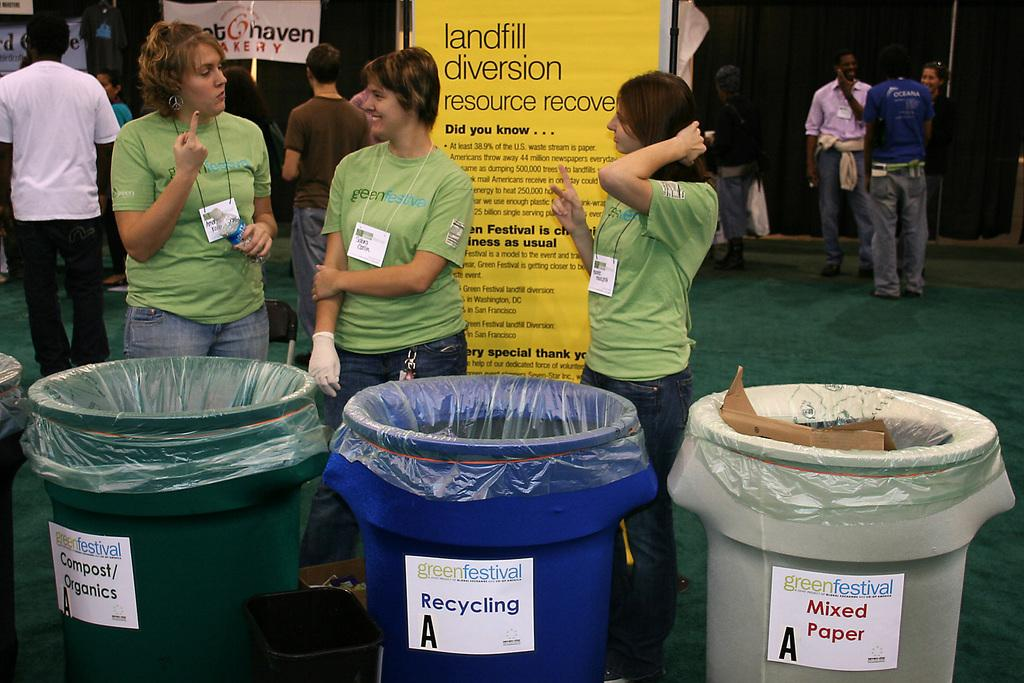<image>
Write a terse but informative summary of the picture. Three bins for different types of waste are lined up at the Green Festival. 